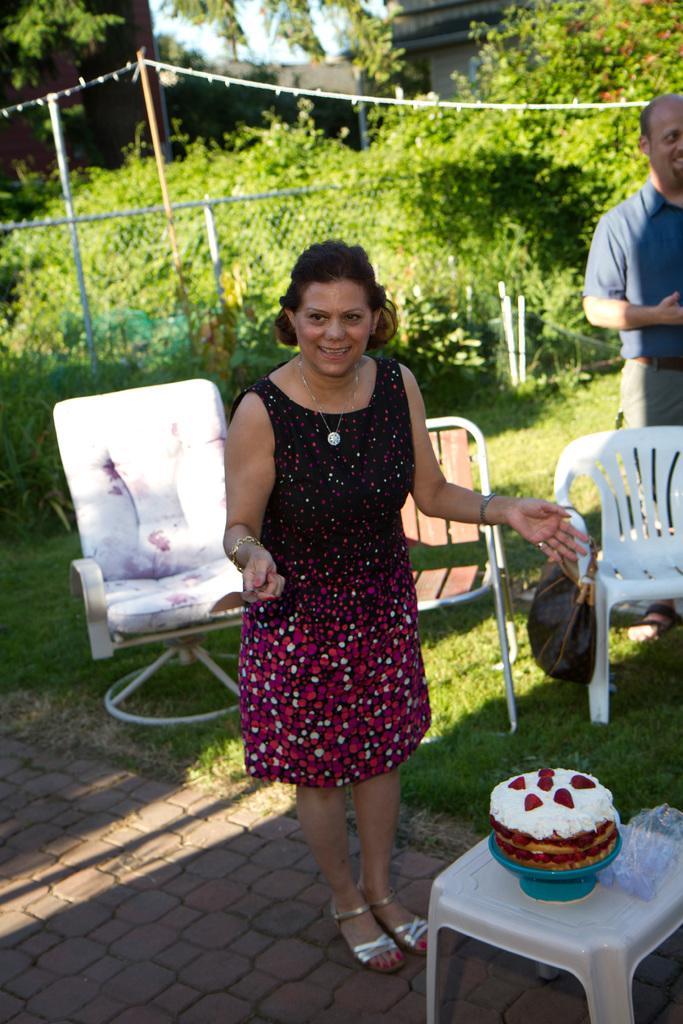Please provide a concise description of this image. Front this woman is standing and smiling. In-front of this woman there is a table, on this table there is a cake. Backside of this woman there are chairs. Far this person is standing. Backside of this man there are plants. 